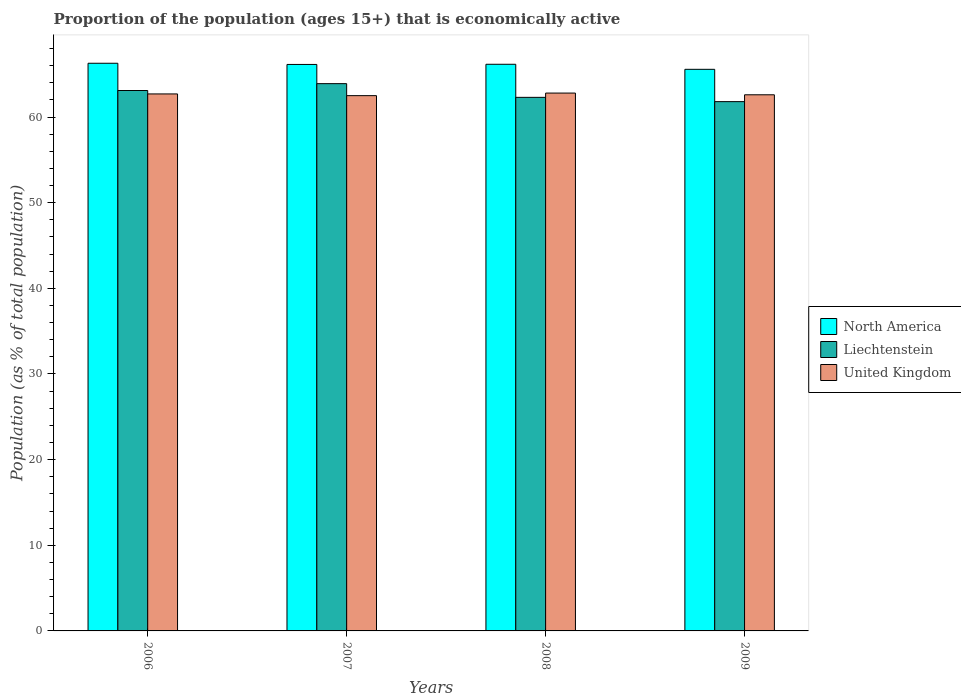How many different coloured bars are there?
Your answer should be very brief. 3. How many groups of bars are there?
Your answer should be compact. 4. Are the number of bars on each tick of the X-axis equal?
Make the answer very short. Yes. How many bars are there on the 1st tick from the right?
Provide a short and direct response. 3. What is the label of the 2nd group of bars from the left?
Ensure brevity in your answer.  2007. In how many cases, is the number of bars for a given year not equal to the number of legend labels?
Provide a succinct answer. 0. What is the proportion of the population that is economically active in Liechtenstein in 2006?
Offer a terse response. 63.1. Across all years, what is the maximum proportion of the population that is economically active in North America?
Provide a succinct answer. 66.28. Across all years, what is the minimum proportion of the population that is economically active in United Kingdom?
Provide a short and direct response. 62.5. In which year was the proportion of the population that is economically active in United Kingdom minimum?
Provide a short and direct response. 2007. What is the total proportion of the population that is economically active in United Kingdom in the graph?
Provide a succinct answer. 250.6. What is the difference between the proportion of the population that is economically active in North America in 2007 and that in 2009?
Provide a short and direct response. 0.57. What is the difference between the proportion of the population that is economically active in United Kingdom in 2008 and the proportion of the population that is economically active in North America in 2009?
Keep it short and to the point. -2.77. What is the average proportion of the population that is economically active in Liechtenstein per year?
Your answer should be very brief. 62.77. In how many years, is the proportion of the population that is economically active in North America greater than 42 %?
Make the answer very short. 4. What is the ratio of the proportion of the population that is economically active in United Kingdom in 2006 to that in 2008?
Ensure brevity in your answer.  1. Is the proportion of the population that is economically active in North America in 2006 less than that in 2009?
Make the answer very short. No. What is the difference between the highest and the second highest proportion of the population that is economically active in Liechtenstein?
Make the answer very short. 0.8. What is the difference between the highest and the lowest proportion of the population that is economically active in United Kingdom?
Give a very brief answer. 0.3. Is the sum of the proportion of the population that is economically active in United Kingdom in 2006 and 2008 greater than the maximum proportion of the population that is economically active in Liechtenstein across all years?
Your answer should be very brief. Yes. What does the 2nd bar from the left in 2007 represents?
Provide a succinct answer. Liechtenstein. What does the 2nd bar from the right in 2006 represents?
Keep it short and to the point. Liechtenstein. How many bars are there?
Your answer should be compact. 12. How many years are there in the graph?
Your answer should be very brief. 4. What is the difference between two consecutive major ticks on the Y-axis?
Your response must be concise. 10. Does the graph contain grids?
Provide a succinct answer. No. What is the title of the graph?
Provide a short and direct response. Proportion of the population (ages 15+) that is economically active. What is the label or title of the Y-axis?
Your response must be concise. Population (as % of total population). What is the Population (as % of total population) of North America in 2006?
Your response must be concise. 66.28. What is the Population (as % of total population) in Liechtenstein in 2006?
Your answer should be very brief. 63.1. What is the Population (as % of total population) in United Kingdom in 2006?
Offer a very short reply. 62.7. What is the Population (as % of total population) in North America in 2007?
Make the answer very short. 66.14. What is the Population (as % of total population) in Liechtenstein in 2007?
Your response must be concise. 63.9. What is the Population (as % of total population) of United Kingdom in 2007?
Provide a short and direct response. 62.5. What is the Population (as % of total population) of North America in 2008?
Give a very brief answer. 66.16. What is the Population (as % of total population) in Liechtenstein in 2008?
Your response must be concise. 62.3. What is the Population (as % of total population) in United Kingdom in 2008?
Ensure brevity in your answer.  62.8. What is the Population (as % of total population) in North America in 2009?
Ensure brevity in your answer.  65.57. What is the Population (as % of total population) of Liechtenstein in 2009?
Provide a succinct answer. 61.8. What is the Population (as % of total population) in United Kingdom in 2009?
Your answer should be very brief. 62.6. Across all years, what is the maximum Population (as % of total population) of North America?
Provide a short and direct response. 66.28. Across all years, what is the maximum Population (as % of total population) of Liechtenstein?
Your answer should be compact. 63.9. Across all years, what is the maximum Population (as % of total population) of United Kingdom?
Provide a succinct answer. 62.8. Across all years, what is the minimum Population (as % of total population) in North America?
Provide a short and direct response. 65.57. Across all years, what is the minimum Population (as % of total population) of Liechtenstein?
Your answer should be very brief. 61.8. Across all years, what is the minimum Population (as % of total population) in United Kingdom?
Offer a terse response. 62.5. What is the total Population (as % of total population) in North America in the graph?
Keep it short and to the point. 264.16. What is the total Population (as % of total population) of Liechtenstein in the graph?
Keep it short and to the point. 251.1. What is the total Population (as % of total population) in United Kingdom in the graph?
Make the answer very short. 250.6. What is the difference between the Population (as % of total population) of North America in 2006 and that in 2007?
Give a very brief answer. 0.14. What is the difference between the Population (as % of total population) of Liechtenstein in 2006 and that in 2007?
Offer a very short reply. -0.8. What is the difference between the Population (as % of total population) of North America in 2006 and that in 2008?
Your answer should be very brief. 0.12. What is the difference between the Population (as % of total population) of North America in 2006 and that in 2009?
Your answer should be very brief. 0.71. What is the difference between the Population (as % of total population) in United Kingdom in 2006 and that in 2009?
Keep it short and to the point. 0.1. What is the difference between the Population (as % of total population) in North America in 2007 and that in 2008?
Offer a very short reply. -0.02. What is the difference between the Population (as % of total population) in United Kingdom in 2007 and that in 2008?
Offer a very short reply. -0.3. What is the difference between the Population (as % of total population) of North America in 2007 and that in 2009?
Give a very brief answer. 0.57. What is the difference between the Population (as % of total population) of United Kingdom in 2007 and that in 2009?
Offer a very short reply. -0.1. What is the difference between the Population (as % of total population) in North America in 2008 and that in 2009?
Give a very brief answer. 0.59. What is the difference between the Population (as % of total population) in Liechtenstein in 2008 and that in 2009?
Provide a short and direct response. 0.5. What is the difference between the Population (as % of total population) of North America in 2006 and the Population (as % of total population) of Liechtenstein in 2007?
Give a very brief answer. 2.38. What is the difference between the Population (as % of total population) of North America in 2006 and the Population (as % of total population) of United Kingdom in 2007?
Provide a succinct answer. 3.78. What is the difference between the Population (as % of total population) of Liechtenstein in 2006 and the Population (as % of total population) of United Kingdom in 2007?
Your answer should be compact. 0.6. What is the difference between the Population (as % of total population) in North America in 2006 and the Population (as % of total population) in Liechtenstein in 2008?
Ensure brevity in your answer.  3.98. What is the difference between the Population (as % of total population) in North America in 2006 and the Population (as % of total population) in United Kingdom in 2008?
Your response must be concise. 3.48. What is the difference between the Population (as % of total population) in Liechtenstein in 2006 and the Population (as % of total population) in United Kingdom in 2008?
Keep it short and to the point. 0.3. What is the difference between the Population (as % of total population) in North America in 2006 and the Population (as % of total population) in Liechtenstein in 2009?
Provide a succinct answer. 4.48. What is the difference between the Population (as % of total population) of North America in 2006 and the Population (as % of total population) of United Kingdom in 2009?
Your answer should be compact. 3.68. What is the difference between the Population (as % of total population) of North America in 2007 and the Population (as % of total population) of Liechtenstein in 2008?
Keep it short and to the point. 3.84. What is the difference between the Population (as % of total population) in North America in 2007 and the Population (as % of total population) in United Kingdom in 2008?
Provide a succinct answer. 3.34. What is the difference between the Population (as % of total population) in Liechtenstein in 2007 and the Population (as % of total population) in United Kingdom in 2008?
Your answer should be compact. 1.1. What is the difference between the Population (as % of total population) in North America in 2007 and the Population (as % of total population) in Liechtenstein in 2009?
Your answer should be compact. 4.34. What is the difference between the Population (as % of total population) of North America in 2007 and the Population (as % of total population) of United Kingdom in 2009?
Your answer should be compact. 3.54. What is the difference between the Population (as % of total population) of North America in 2008 and the Population (as % of total population) of Liechtenstein in 2009?
Give a very brief answer. 4.36. What is the difference between the Population (as % of total population) of North America in 2008 and the Population (as % of total population) of United Kingdom in 2009?
Provide a short and direct response. 3.56. What is the difference between the Population (as % of total population) in Liechtenstein in 2008 and the Population (as % of total population) in United Kingdom in 2009?
Your answer should be very brief. -0.3. What is the average Population (as % of total population) in North America per year?
Give a very brief answer. 66.04. What is the average Population (as % of total population) of Liechtenstein per year?
Make the answer very short. 62.77. What is the average Population (as % of total population) in United Kingdom per year?
Ensure brevity in your answer.  62.65. In the year 2006, what is the difference between the Population (as % of total population) in North America and Population (as % of total population) in Liechtenstein?
Offer a very short reply. 3.18. In the year 2006, what is the difference between the Population (as % of total population) of North America and Population (as % of total population) of United Kingdom?
Provide a succinct answer. 3.58. In the year 2007, what is the difference between the Population (as % of total population) of North America and Population (as % of total population) of Liechtenstein?
Give a very brief answer. 2.24. In the year 2007, what is the difference between the Population (as % of total population) in North America and Population (as % of total population) in United Kingdom?
Keep it short and to the point. 3.64. In the year 2007, what is the difference between the Population (as % of total population) of Liechtenstein and Population (as % of total population) of United Kingdom?
Keep it short and to the point. 1.4. In the year 2008, what is the difference between the Population (as % of total population) of North America and Population (as % of total population) of Liechtenstein?
Keep it short and to the point. 3.86. In the year 2008, what is the difference between the Population (as % of total population) in North America and Population (as % of total population) in United Kingdom?
Your answer should be compact. 3.36. In the year 2009, what is the difference between the Population (as % of total population) in North America and Population (as % of total population) in Liechtenstein?
Provide a short and direct response. 3.77. In the year 2009, what is the difference between the Population (as % of total population) in North America and Population (as % of total population) in United Kingdom?
Provide a short and direct response. 2.97. In the year 2009, what is the difference between the Population (as % of total population) of Liechtenstein and Population (as % of total population) of United Kingdom?
Provide a succinct answer. -0.8. What is the ratio of the Population (as % of total population) of Liechtenstein in 2006 to that in 2007?
Provide a succinct answer. 0.99. What is the ratio of the Population (as % of total population) of Liechtenstein in 2006 to that in 2008?
Make the answer very short. 1.01. What is the ratio of the Population (as % of total population) in United Kingdom in 2006 to that in 2008?
Make the answer very short. 1. What is the ratio of the Population (as % of total population) in North America in 2006 to that in 2009?
Ensure brevity in your answer.  1.01. What is the ratio of the Population (as % of total population) of Liechtenstein in 2007 to that in 2008?
Give a very brief answer. 1.03. What is the ratio of the Population (as % of total population) of North America in 2007 to that in 2009?
Ensure brevity in your answer.  1.01. What is the ratio of the Population (as % of total population) in Liechtenstein in 2007 to that in 2009?
Keep it short and to the point. 1.03. What is the ratio of the Population (as % of total population) in United Kingdom in 2007 to that in 2009?
Your answer should be compact. 1. What is the difference between the highest and the second highest Population (as % of total population) of North America?
Provide a succinct answer. 0.12. What is the difference between the highest and the lowest Population (as % of total population) of North America?
Provide a short and direct response. 0.71. 